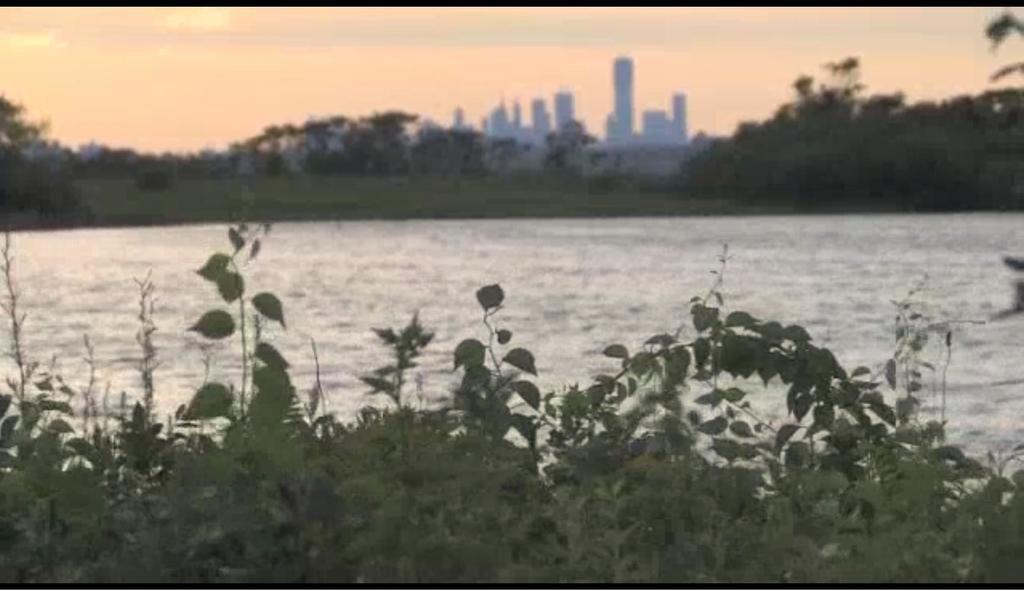In one or two sentences, can you explain what this image depicts? In this picture we can see plants and water, beside the water we can see buildings, trees and we can see sky in the background. 